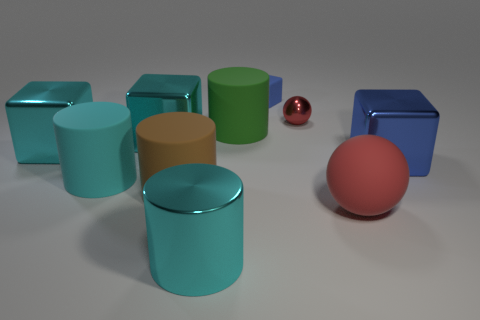Is the big green thing made of the same material as the small cube?
Give a very brief answer. Yes. What number of things are rubber things to the right of the large green cylinder or large cyan things that are on the left side of the brown rubber thing?
Your answer should be compact. 5. There is a metallic object that is the same shape as the cyan matte object; what is its color?
Ensure brevity in your answer.  Cyan. What number of shiny balls have the same color as the matte ball?
Keep it short and to the point. 1. Is the color of the small rubber block the same as the shiny cylinder?
Keep it short and to the point. No. How many objects are blue blocks that are right of the tiny sphere or small gray metal things?
Ensure brevity in your answer.  1. What color is the large block that is right of the big matte thing that is behind the blue block that is in front of the small red metallic ball?
Keep it short and to the point. Blue. There is a cylinder that is made of the same material as the small sphere; what is its color?
Offer a very short reply. Cyan. How many large blue blocks have the same material as the big red ball?
Your answer should be compact. 0. There is a rubber cylinder to the right of the cyan metal cylinder; is it the same size as the small blue matte block?
Offer a terse response. No. 